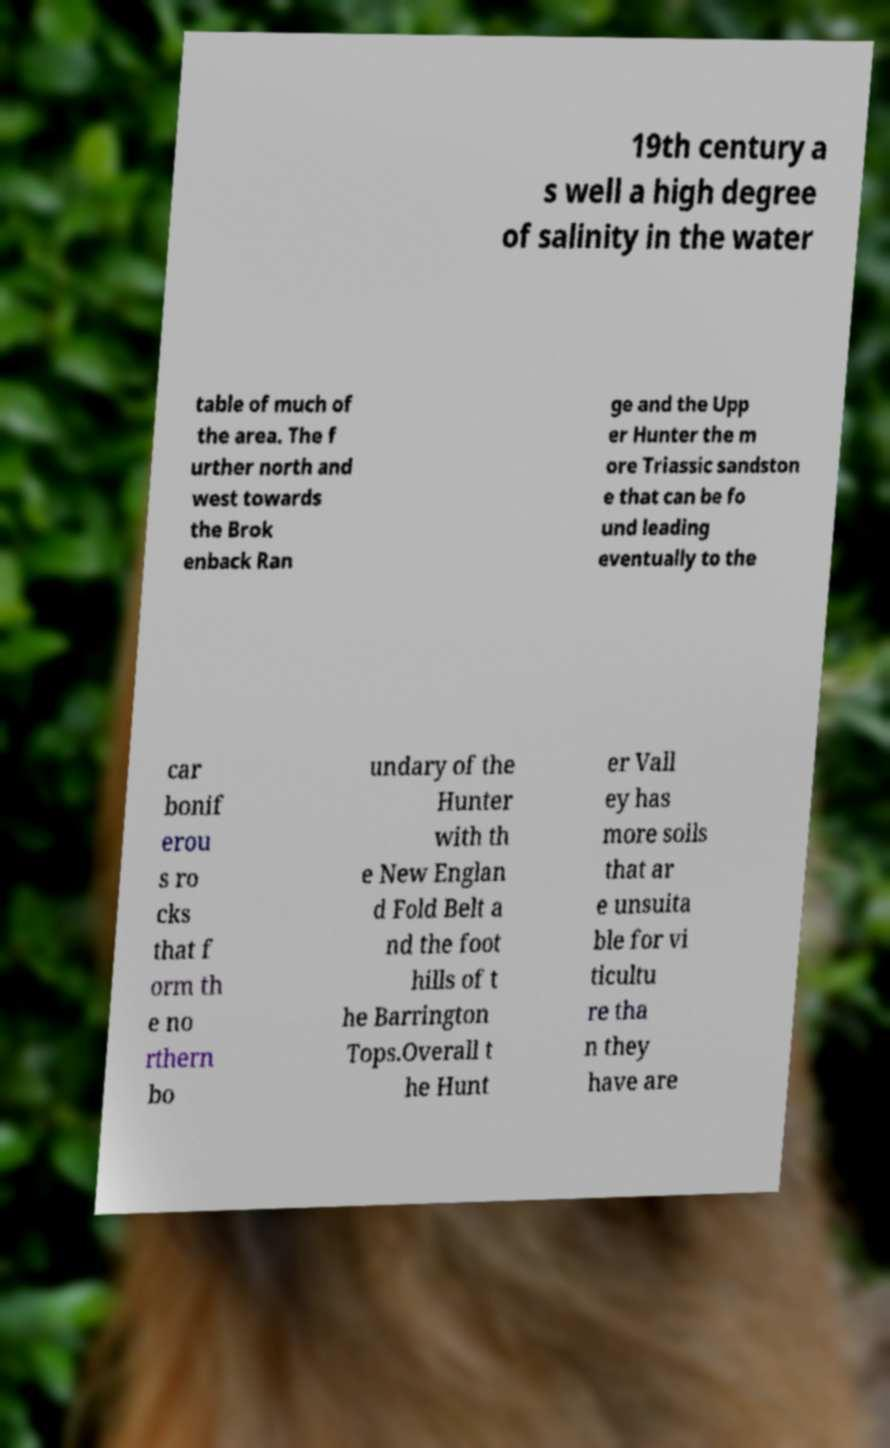For documentation purposes, I need the text within this image transcribed. Could you provide that? 19th century a s well a high degree of salinity in the water table of much of the area. The f urther north and west towards the Brok enback Ran ge and the Upp er Hunter the m ore Triassic sandston e that can be fo und leading eventually to the car bonif erou s ro cks that f orm th e no rthern bo undary of the Hunter with th e New Englan d Fold Belt a nd the foot hills of t he Barrington Tops.Overall t he Hunt er Vall ey has more soils that ar e unsuita ble for vi ticultu re tha n they have are 